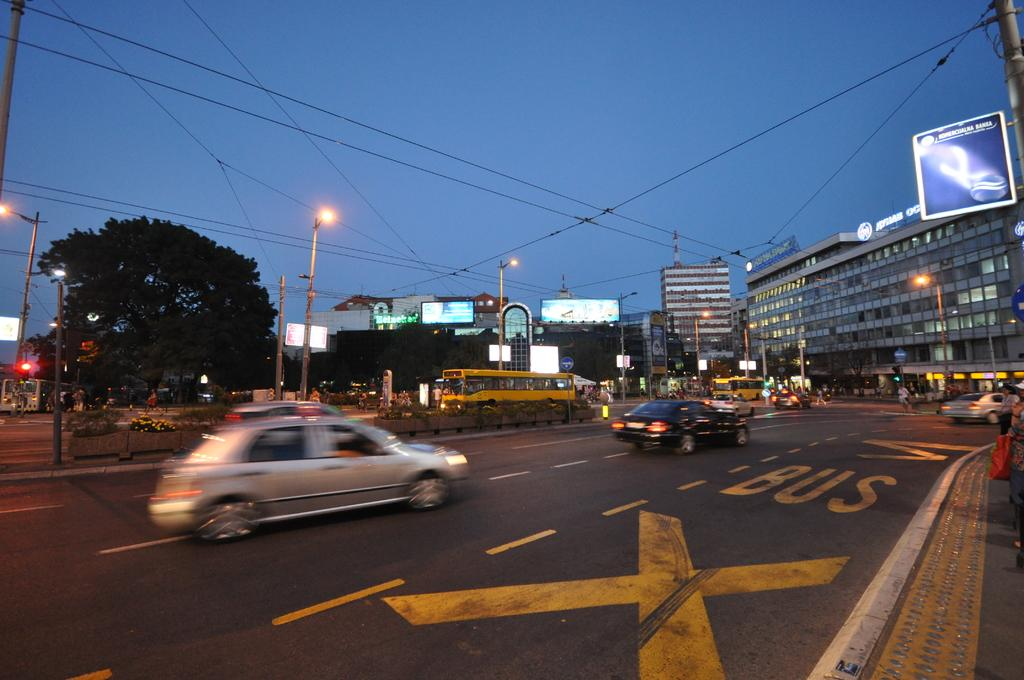<image>
Share a concise interpretation of the image provided. Cars are driving down a three lane road with a bus lane to the far right. 